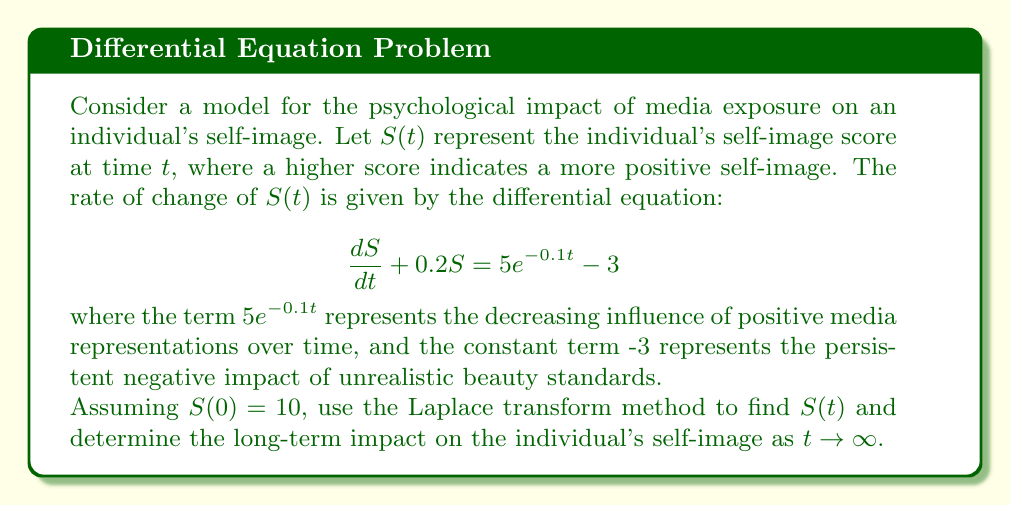Provide a solution to this math problem. Let's solve this step-by-step using the Laplace transform method:

1) First, let's take the Laplace transform of both sides of the equation:

   $\mathcal{L}\{\frac{dS}{dt} + 0.2S\} = \mathcal{L}\{5e^{-0.1t} - 3\}$

2) Using Laplace transform properties:

   $s\mathcal{L}\{S\} - S(0) + 0.2\mathcal{L}\{S\} = \frac{5}{s+0.1} - \frac{3}{s}$

3) Let $\mathcal{L}\{S\} = X(s)$. Substituting $S(0) = 10$:

   $sX(s) - 10 + 0.2X(s) = \frac{5}{s+0.1} - \frac{3}{s}$

4) Rearranging:

   $(s + 0.2)X(s) = 10 + \frac{5}{s+0.1} - \frac{3}{s}$

5) Solving for $X(s)$:

   $X(s) = \frac{10}{s + 0.2} + \frac{5}{(s + 0.2)(s + 0.1)} - \frac{3}{s(s + 0.2)}$

6) Using partial fraction decomposition:

   $X(s) = \frac{10}{s + 0.2} + \frac{50}{s + 0.2} - \frac{45}{s + 0.1} - \frac{3}{s} + \frac{3}{s + 0.2}$

7) Taking the inverse Laplace transform:

   $S(t) = 63e^{-0.2t} - 45e^{-0.1t} - 3 + 15$

8) Simplifying:

   $S(t) = 63e^{-0.2t} - 45e^{-0.1t} + 12$

9) To find the long-term impact as $t \to \infty$, we take the limit:

   $\lim_{t \to \infty} S(t) = \lim_{t \to \infty} (63e^{-0.2t} - 45e^{-0.1t} + 12) = 12$
Answer: $S(t) = 63e^{-0.2t} - 45e^{-0.1t} + 12$; Long-term impact: $S(\infty) = 12$ 